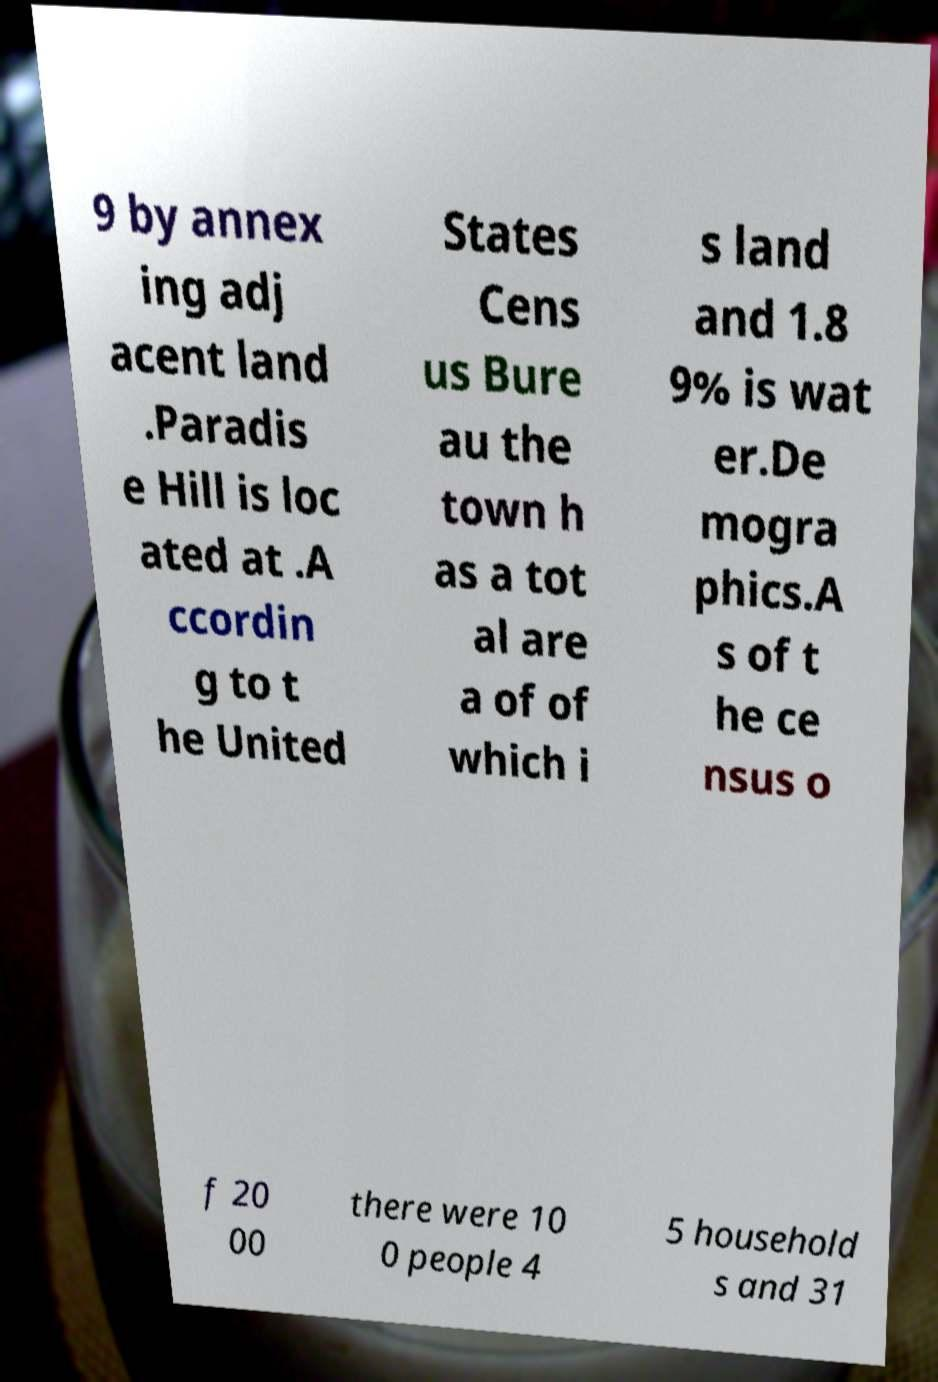Can you read and provide the text displayed in the image?This photo seems to have some interesting text. Can you extract and type it out for me? 9 by annex ing adj acent land .Paradis e Hill is loc ated at .A ccordin g to t he United States Cens us Bure au the town h as a tot al are a of of which i s land and 1.8 9% is wat er.De mogra phics.A s of t he ce nsus o f 20 00 there were 10 0 people 4 5 household s and 31 